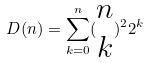Convert formula to latex. <formula><loc_0><loc_0><loc_500><loc_500>D ( n ) = \sum _ { k = 0 } ^ { n } ( \begin{matrix} n \\ k \end{matrix} ) ^ { 2 } 2 ^ { k }</formula> 